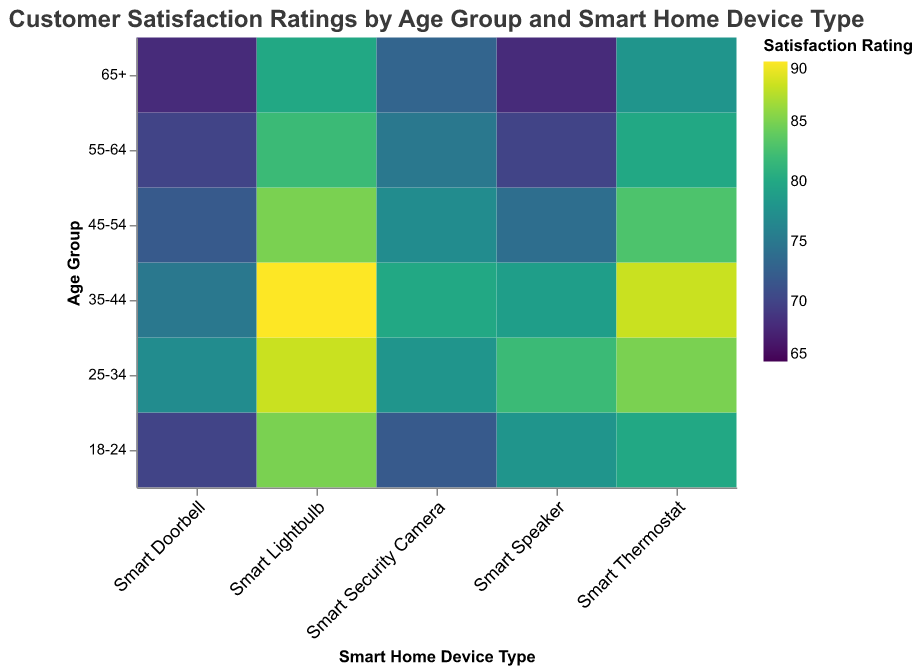What is the title of the heatmap? The title is usually at the top of the figure and labeled clearly as the main description of the visual content. In this case, read the topmost text in the figure.
Answer: Customer Satisfaction Ratings by Age Group and Smart Home Device Type Which age group gave the highest satisfaction rating for Smart Lightbulbs? Find the highest value in the "Smart Lightbulb" column and note the corresponding age group. The highest satisfaction rating in the Smart Lightbulb column is 90.
Answer: 35-44 What is the color scheme of the heatmap? The colors in the heatmap are usually described in the legend. Look at the legend to identify the color scheme used.
Answer: viridis How many age groups are included in the heatmap? Count the unique labels on the Y-axis, which represents different age groups.
Answer: 6 What is the satisfaction rating for Smart Doorbells in the 18-24 age group? Locate the cell that aligns both with the 18-24 row and the Smart Doorbell column. This cell contains the rating value.
Answer: 70 Which smart home device has the lowest overall satisfaction rating, and what is that rating? Identify the smallest value in the entire heatmap and note the corresponding device type. The lowest rating is 68 for Smart Doorbell and Smart Speaker in different age groups.
Answer: Smart Doorbell, 68 What is the average satisfaction rating of Smart Thermostats across all age groups? Sum the satisfaction ratings for Smart Thermostats from all age groups and divide by the number of age groups (6). (80+85+88+83+80+78)/6 = 82.33
Answer: 82.33 Which age group has the most varied satisfaction ratings across all device types? Calculate the range (difference between the maximum and minimum values) of ratings for each age group. The age group with the highest range has the most varied ratings. The 18-24 age group has a range of 85-70 = 15, the 25-34 group has a range of 88-77 = 11, the 35-44 group has a range of 90-75 = 15, the 45-54 group has a range of 85-72 = 13, the 55-64 group has a range of 82-70 = 12, and the 65+ group has a range of 80-68 = 12.
Answer: 18-24 and 35-44 Compare the satisfaction ratings for Smart Security Cameras and Smart Doorbells for the 45-54 age group. Which one is higher, and by how much? Look at the ratings for the 45-54 age group in both the Smart Security Cameras and Smart Doorbells columns. Subtract the lower rating from the higher rating. Ratings are 77 and 72, and the difference is 5.
Answer: Smart Security Camera, 5 For which device does the 65+ age group give the highest satisfaction rating? Find the highest value in the 65+ age group's row and note the corresponding device. The 65+ group's highest rating is 80.
Answer: Smart Lightbulb 